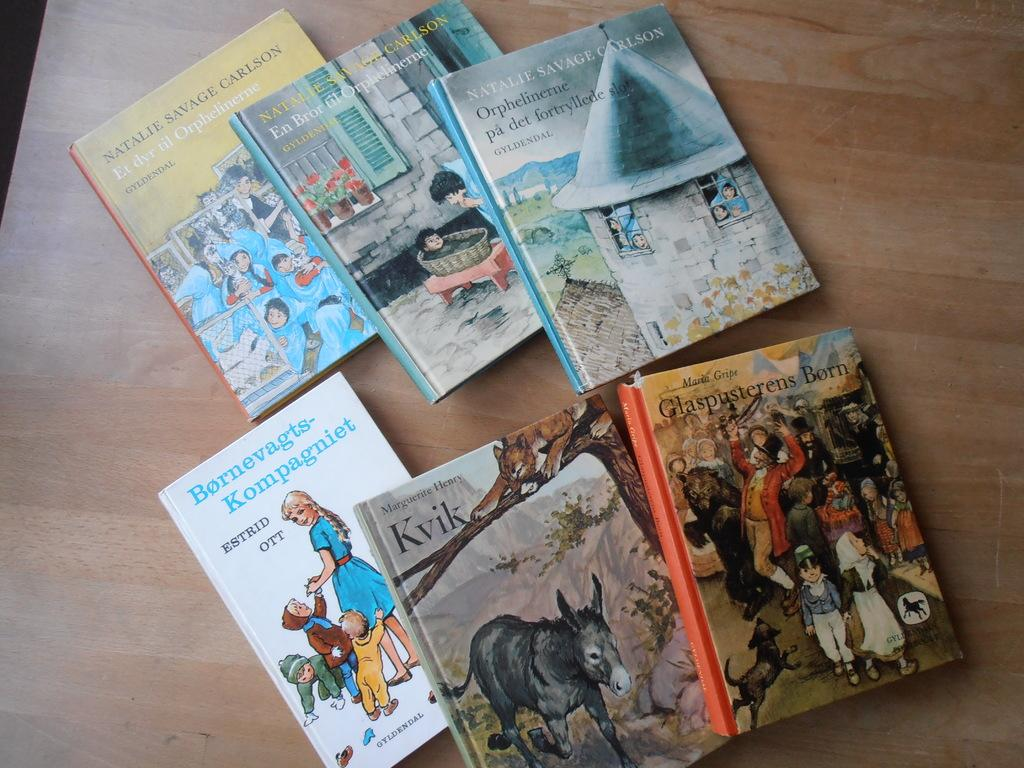<image>
Offer a succinct explanation of the picture presented. Six different books are all stacked on a wooden surface with one being Kvik by Marguerite Henry. 